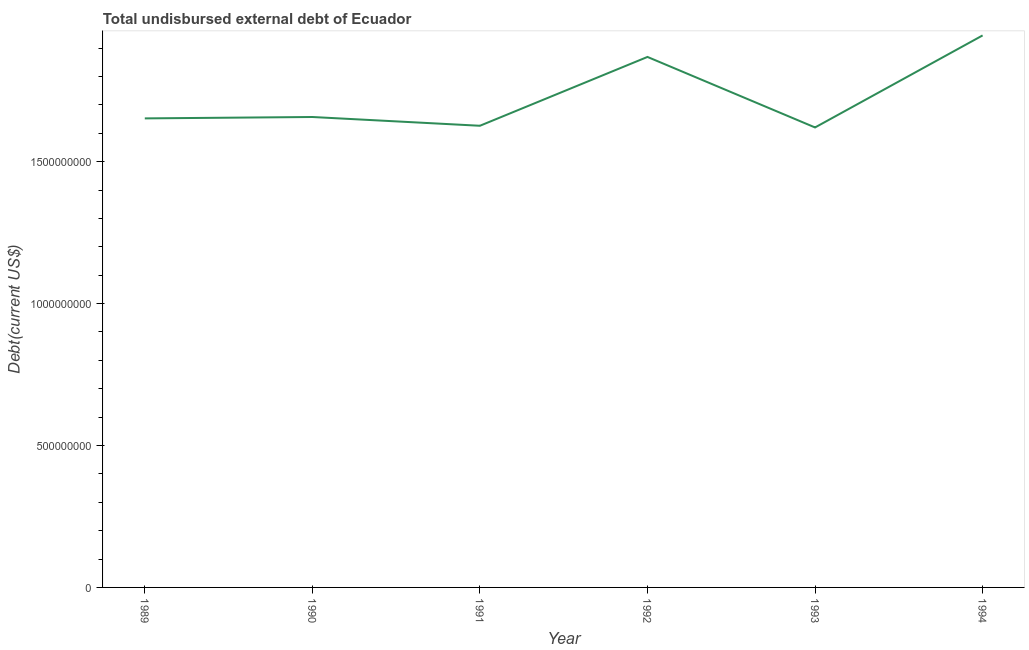What is the total debt in 1990?
Your answer should be very brief. 1.66e+09. Across all years, what is the maximum total debt?
Ensure brevity in your answer.  1.94e+09. Across all years, what is the minimum total debt?
Your answer should be very brief. 1.62e+09. In which year was the total debt minimum?
Give a very brief answer. 1993. What is the sum of the total debt?
Give a very brief answer. 1.04e+1. What is the difference between the total debt in 1992 and 1994?
Offer a terse response. -7.58e+07. What is the average total debt per year?
Your answer should be very brief. 1.73e+09. What is the median total debt?
Provide a short and direct response. 1.65e+09. In how many years, is the total debt greater than 1300000000 US$?
Your answer should be very brief. 6. Do a majority of the years between 1990 and 1989 (inclusive) have total debt greater than 1200000000 US$?
Provide a short and direct response. No. What is the ratio of the total debt in 1990 to that in 1991?
Make the answer very short. 1.02. What is the difference between the highest and the second highest total debt?
Offer a terse response. 7.58e+07. What is the difference between the highest and the lowest total debt?
Offer a very short reply. 3.24e+08. What is the difference between two consecutive major ticks on the Y-axis?
Give a very brief answer. 5.00e+08. Are the values on the major ticks of Y-axis written in scientific E-notation?
Provide a succinct answer. No. Does the graph contain any zero values?
Provide a short and direct response. No. What is the title of the graph?
Offer a very short reply. Total undisbursed external debt of Ecuador. What is the label or title of the X-axis?
Your answer should be very brief. Year. What is the label or title of the Y-axis?
Your answer should be compact. Debt(current US$). What is the Debt(current US$) in 1989?
Offer a very short reply. 1.65e+09. What is the Debt(current US$) in 1990?
Keep it short and to the point. 1.66e+09. What is the Debt(current US$) of 1991?
Keep it short and to the point. 1.63e+09. What is the Debt(current US$) of 1992?
Ensure brevity in your answer.  1.87e+09. What is the Debt(current US$) of 1993?
Provide a succinct answer. 1.62e+09. What is the Debt(current US$) in 1994?
Offer a terse response. 1.94e+09. What is the difference between the Debt(current US$) in 1989 and 1990?
Provide a succinct answer. -4.90e+06. What is the difference between the Debt(current US$) in 1989 and 1991?
Give a very brief answer. 2.60e+07. What is the difference between the Debt(current US$) in 1989 and 1992?
Give a very brief answer. -2.16e+08. What is the difference between the Debt(current US$) in 1989 and 1993?
Provide a short and direct response. 3.19e+07. What is the difference between the Debt(current US$) in 1989 and 1994?
Ensure brevity in your answer.  -2.92e+08. What is the difference between the Debt(current US$) in 1990 and 1991?
Ensure brevity in your answer.  3.09e+07. What is the difference between the Debt(current US$) in 1990 and 1992?
Provide a succinct answer. -2.12e+08. What is the difference between the Debt(current US$) in 1990 and 1993?
Give a very brief answer. 3.68e+07. What is the difference between the Debt(current US$) in 1990 and 1994?
Provide a short and direct response. -2.87e+08. What is the difference between the Debt(current US$) in 1991 and 1992?
Keep it short and to the point. -2.42e+08. What is the difference between the Debt(current US$) in 1991 and 1993?
Offer a terse response. 5.92e+06. What is the difference between the Debt(current US$) in 1991 and 1994?
Give a very brief answer. -3.18e+08. What is the difference between the Debt(current US$) in 1992 and 1993?
Your response must be concise. 2.48e+08. What is the difference between the Debt(current US$) in 1992 and 1994?
Your answer should be very brief. -7.58e+07. What is the difference between the Debt(current US$) in 1993 and 1994?
Your response must be concise. -3.24e+08. What is the ratio of the Debt(current US$) in 1989 to that in 1990?
Provide a succinct answer. 1. What is the ratio of the Debt(current US$) in 1989 to that in 1991?
Keep it short and to the point. 1.02. What is the ratio of the Debt(current US$) in 1989 to that in 1992?
Your answer should be very brief. 0.88. What is the ratio of the Debt(current US$) in 1989 to that in 1993?
Make the answer very short. 1.02. What is the ratio of the Debt(current US$) in 1989 to that in 1994?
Give a very brief answer. 0.85. What is the ratio of the Debt(current US$) in 1990 to that in 1992?
Your answer should be very brief. 0.89. What is the ratio of the Debt(current US$) in 1990 to that in 1994?
Offer a terse response. 0.85. What is the ratio of the Debt(current US$) in 1991 to that in 1992?
Keep it short and to the point. 0.87. What is the ratio of the Debt(current US$) in 1991 to that in 1993?
Your answer should be compact. 1. What is the ratio of the Debt(current US$) in 1991 to that in 1994?
Your response must be concise. 0.84. What is the ratio of the Debt(current US$) in 1992 to that in 1993?
Make the answer very short. 1.15. What is the ratio of the Debt(current US$) in 1993 to that in 1994?
Give a very brief answer. 0.83. 